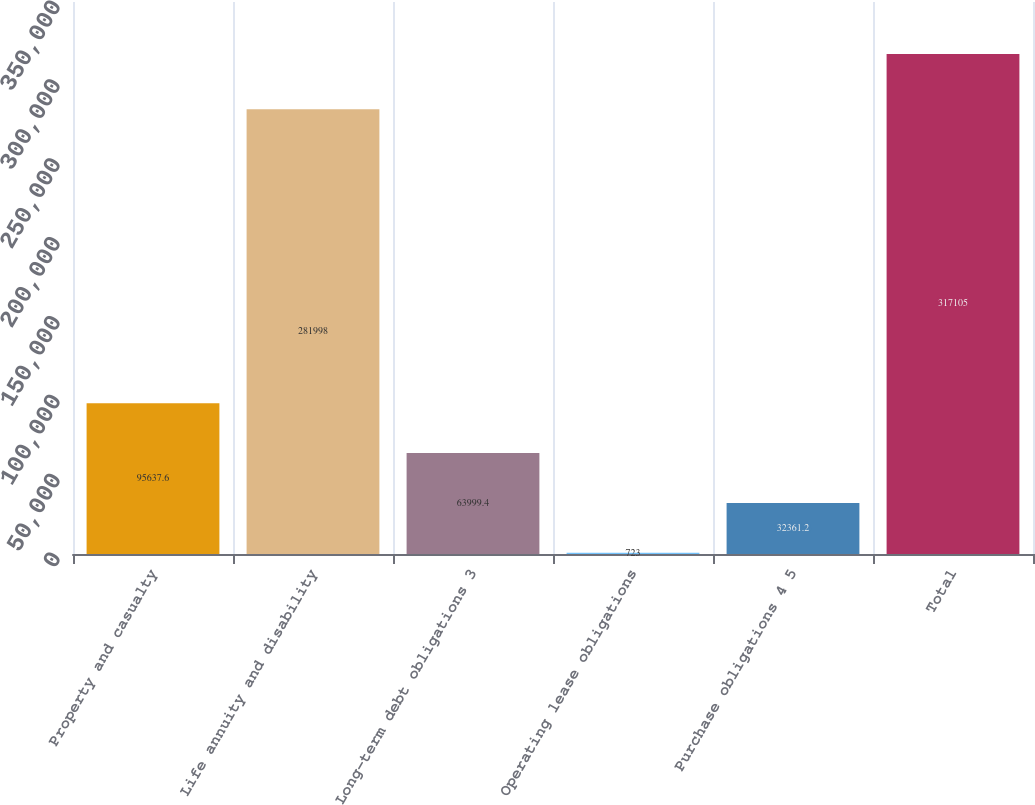<chart> <loc_0><loc_0><loc_500><loc_500><bar_chart><fcel>Property and casualty<fcel>Life annuity and disability<fcel>Long-term debt obligations 3<fcel>Operating lease obligations<fcel>Purchase obligations 4 5<fcel>Total<nl><fcel>95637.6<fcel>281998<fcel>63999.4<fcel>723<fcel>32361.2<fcel>317105<nl></chart> 